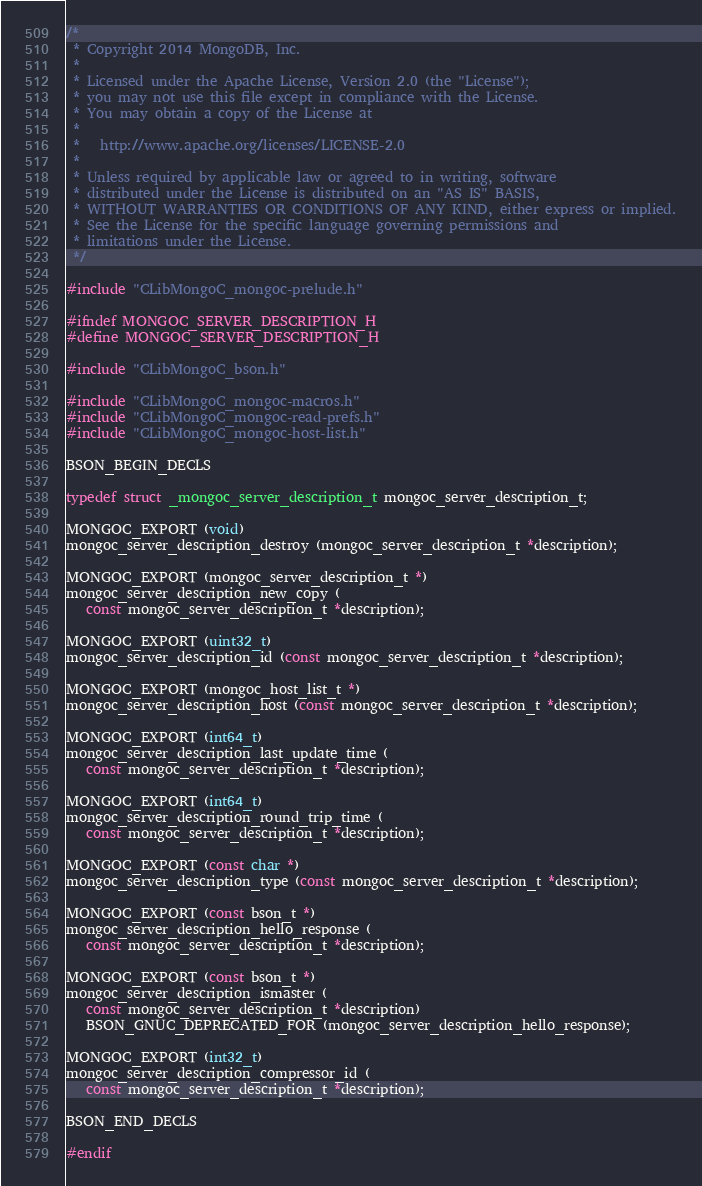<code> <loc_0><loc_0><loc_500><loc_500><_C_>/*
 * Copyright 2014 MongoDB, Inc.
 *
 * Licensed under the Apache License, Version 2.0 (the "License");
 * you may not use this file except in compliance with the License.
 * You may obtain a copy of the License at
 *
 *   http://www.apache.org/licenses/LICENSE-2.0
 *
 * Unless required by applicable law or agreed to in writing, software
 * distributed under the License is distributed on an "AS IS" BASIS,
 * WITHOUT WARRANTIES OR CONDITIONS OF ANY KIND, either express or implied.
 * See the License for the specific language governing permissions and
 * limitations under the License.
 */

#include "CLibMongoC_mongoc-prelude.h"

#ifndef MONGOC_SERVER_DESCRIPTION_H
#define MONGOC_SERVER_DESCRIPTION_H

#include "CLibMongoC_bson.h"

#include "CLibMongoC_mongoc-macros.h"
#include "CLibMongoC_mongoc-read-prefs.h"
#include "CLibMongoC_mongoc-host-list.h"

BSON_BEGIN_DECLS

typedef struct _mongoc_server_description_t mongoc_server_description_t;

MONGOC_EXPORT (void)
mongoc_server_description_destroy (mongoc_server_description_t *description);

MONGOC_EXPORT (mongoc_server_description_t *)
mongoc_server_description_new_copy (
   const mongoc_server_description_t *description);

MONGOC_EXPORT (uint32_t)
mongoc_server_description_id (const mongoc_server_description_t *description);

MONGOC_EXPORT (mongoc_host_list_t *)
mongoc_server_description_host (const mongoc_server_description_t *description);

MONGOC_EXPORT (int64_t)
mongoc_server_description_last_update_time (
   const mongoc_server_description_t *description);

MONGOC_EXPORT (int64_t)
mongoc_server_description_round_trip_time (
   const mongoc_server_description_t *description);

MONGOC_EXPORT (const char *)
mongoc_server_description_type (const mongoc_server_description_t *description);

MONGOC_EXPORT (const bson_t *)
mongoc_server_description_hello_response (
   const mongoc_server_description_t *description);

MONGOC_EXPORT (const bson_t *)
mongoc_server_description_ismaster (
   const mongoc_server_description_t *description)
   BSON_GNUC_DEPRECATED_FOR (mongoc_server_description_hello_response);

MONGOC_EXPORT (int32_t)
mongoc_server_description_compressor_id (
   const mongoc_server_description_t *description);

BSON_END_DECLS

#endif
</code> 